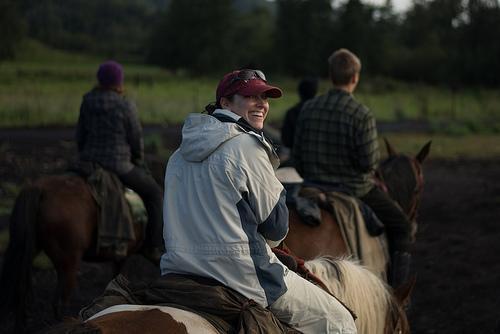How many people are looking at the camera?
Give a very brief answer. 1. 